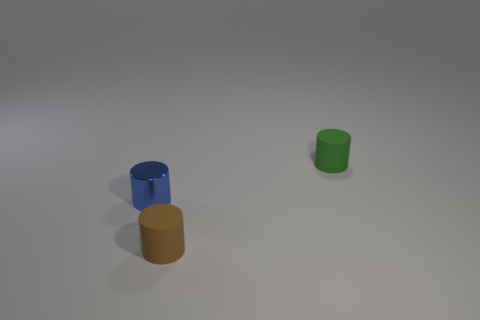Add 1 small green cubes. How many objects exist? 4 Subtract all green cylinders. How many cylinders are left? 2 Subtract all matte cylinders. How many cylinders are left? 1 Subtract all green cylinders. Subtract all green balls. How many cylinders are left? 2 Subtract all green balls. How many purple cylinders are left? 0 Subtract all large cyan matte objects. Subtract all brown things. How many objects are left? 2 Add 2 small matte cylinders. How many small matte cylinders are left? 4 Add 1 small cylinders. How many small cylinders exist? 4 Subtract 0 blue blocks. How many objects are left? 3 Subtract 1 cylinders. How many cylinders are left? 2 